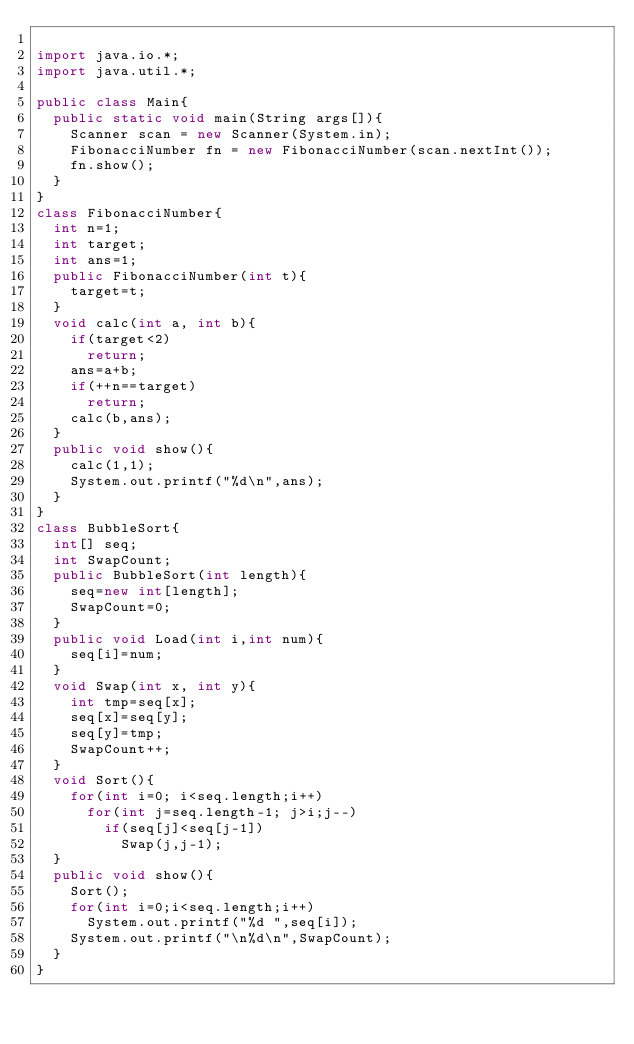Convert code to text. <code><loc_0><loc_0><loc_500><loc_500><_Java_>
import java.io.*;
import java.util.*;

public class Main{
	public static void main(String args[]){
		Scanner scan = new Scanner(System.in);
		FibonacciNumber fn = new FibonacciNumber(scan.nextInt());
		fn.show();
	}
}
class FibonacciNumber{
	int n=1;
	int target;
	int ans=1;
	public FibonacciNumber(int t){
		target=t;
	}
	void calc(int a, int b){
		if(target<2)
			return;
		ans=a+b;
		if(++n==target)
			return;
		calc(b,ans);
	}
	public void show(){
		calc(1,1);
		System.out.printf("%d\n",ans);
	}
}
class BubbleSort{
	int[] seq;
	int SwapCount;
	public BubbleSort(int length){
		seq=new int[length];
		SwapCount=0;
	}
	public void Load(int i,int num){
		seq[i]=num;
	}
	void Swap(int x, int y){
		int tmp=seq[x];
		seq[x]=seq[y];
		seq[y]=tmp;
		SwapCount++;
	}
	void Sort(){
		for(int i=0; i<seq.length;i++)
			for(int j=seq.length-1; j>i;j--)
				if(seq[j]<seq[j-1])
					Swap(j,j-1);
	}
	public void show(){
		Sort();
		for(int i=0;i<seq.length;i++)
			System.out.printf("%d ",seq[i]);
		System.out.printf("\n%d\n",SwapCount);
	}
}</code> 